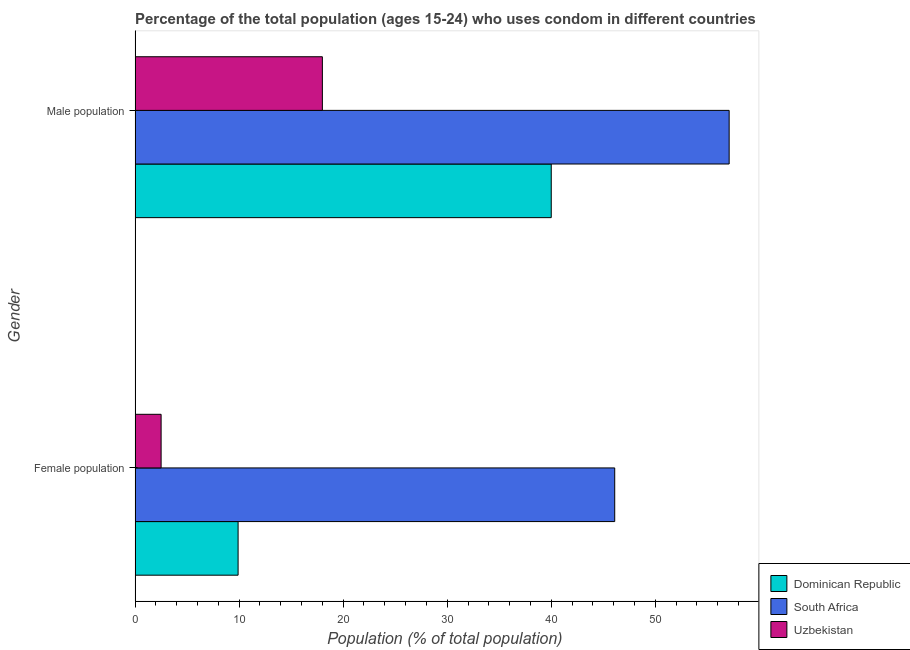Are the number of bars per tick equal to the number of legend labels?
Provide a short and direct response. Yes. Are the number of bars on each tick of the Y-axis equal?
Make the answer very short. Yes. How many bars are there on the 2nd tick from the bottom?
Make the answer very short. 3. What is the label of the 1st group of bars from the top?
Your response must be concise. Male population. What is the male population in Uzbekistan?
Your response must be concise. 18. Across all countries, what is the maximum male population?
Keep it short and to the point. 57.1. Across all countries, what is the minimum female population?
Ensure brevity in your answer.  2.5. In which country was the female population maximum?
Your response must be concise. South Africa. In which country was the male population minimum?
Keep it short and to the point. Uzbekistan. What is the total male population in the graph?
Provide a short and direct response. 115.1. What is the difference between the female population in Uzbekistan and the male population in South Africa?
Provide a short and direct response. -54.6. What is the average male population per country?
Give a very brief answer. 38.37. What is the difference between the male population and female population in Uzbekistan?
Offer a very short reply. 15.5. What is the ratio of the male population in Uzbekistan to that in South Africa?
Your response must be concise. 0.32. In how many countries, is the male population greater than the average male population taken over all countries?
Your answer should be very brief. 2. What does the 2nd bar from the top in Male population represents?
Give a very brief answer. South Africa. What does the 2nd bar from the bottom in Female population represents?
Offer a terse response. South Africa. How many bars are there?
Offer a very short reply. 6. What is the difference between two consecutive major ticks on the X-axis?
Your response must be concise. 10. Are the values on the major ticks of X-axis written in scientific E-notation?
Give a very brief answer. No. How are the legend labels stacked?
Give a very brief answer. Vertical. What is the title of the graph?
Keep it short and to the point. Percentage of the total population (ages 15-24) who uses condom in different countries. Does "Sierra Leone" appear as one of the legend labels in the graph?
Offer a terse response. No. What is the label or title of the X-axis?
Offer a very short reply. Population (% of total population) . What is the label or title of the Y-axis?
Offer a very short reply. Gender. What is the Population (% of total population)  in Dominican Republic in Female population?
Give a very brief answer. 9.9. What is the Population (% of total population)  in South Africa in Female population?
Offer a very short reply. 46.1. What is the Population (% of total population)  of Uzbekistan in Female population?
Offer a very short reply. 2.5. What is the Population (% of total population)  in South Africa in Male population?
Make the answer very short. 57.1. Across all Gender, what is the maximum Population (% of total population)  of South Africa?
Your answer should be very brief. 57.1. Across all Gender, what is the minimum Population (% of total population)  of Dominican Republic?
Your answer should be compact. 9.9. Across all Gender, what is the minimum Population (% of total population)  of South Africa?
Provide a short and direct response. 46.1. Across all Gender, what is the minimum Population (% of total population)  in Uzbekistan?
Ensure brevity in your answer.  2.5. What is the total Population (% of total population)  of Dominican Republic in the graph?
Your response must be concise. 49.9. What is the total Population (% of total population)  of South Africa in the graph?
Provide a succinct answer. 103.2. What is the difference between the Population (% of total population)  of Dominican Republic in Female population and that in Male population?
Your answer should be compact. -30.1. What is the difference between the Population (% of total population)  in South Africa in Female population and that in Male population?
Keep it short and to the point. -11. What is the difference between the Population (% of total population)  of Uzbekistan in Female population and that in Male population?
Your answer should be very brief. -15.5. What is the difference between the Population (% of total population)  in Dominican Republic in Female population and the Population (% of total population)  in South Africa in Male population?
Make the answer very short. -47.2. What is the difference between the Population (% of total population)  of Dominican Republic in Female population and the Population (% of total population)  of Uzbekistan in Male population?
Your answer should be compact. -8.1. What is the difference between the Population (% of total population)  of South Africa in Female population and the Population (% of total population)  of Uzbekistan in Male population?
Provide a short and direct response. 28.1. What is the average Population (% of total population)  of Dominican Republic per Gender?
Ensure brevity in your answer.  24.95. What is the average Population (% of total population)  in South Africa per Gender?
Provide a short and direct response. 51.6. What is the average Population (% of total population)  of Uzbekistan per Gender?
Your answer should be compact. 10.25. What is the difference between the Population (% of total population)  in Dominican Republic and Population (% of total population)  in South Africa in Female population?
Your response must be concise. -36.2. What is the difference between the Population (% of total population)  of Dominican Republic and Population (% of total population)  of Uzbekistan in Female population?
Make the answer very short. 7.4. What is the difference between the Population (% of total population)  of South Africa and Population (% of total population)  of Uzbekistan in Female population?
Keep it short and to the point. 43.6. What is the difference between the Population (% of total population)  in Dominican Republic and Population (% of total population)  in South Africa in Male population?
Provide a short and direct response. -17.1. What is the difference between the Population (% of total population)  in South Africa and Population (% of total population)  in Uzbekistan in Male population?
Your answer should be very brief. 39.1. What is the ratio of the Population (% of total population)  in Dominican Republic in Female population to that in Male population?
Offer a terse response. 0.25. What is the ratio of the Population (% of total population)  in South Africa in Female population to that in Male population?
Your answer should be very brief. 0.81. What is the ratio of the Population (% of total population)  of Uzbekistan in Female population to that in Male population?
Provide a succinct answer. 0.14. What is the difference between the highest and the second highest Population (% of total population)  of Dominican Republic?
Ensure brevity in your answer.  30.1. What is the difference between the highest and the second highest Population (% of total population)  in Uzbekistan?
Your answer should be very brief. 15.5. What is the difference between the highest and the lowest Population (% of total population)  in Dominican Republic?
Your answer should be compact. 30.1. What is the difference between the highest and the lowest Population (% of total population)  of South Africa?
Ensure brevity in your answer.  11. 